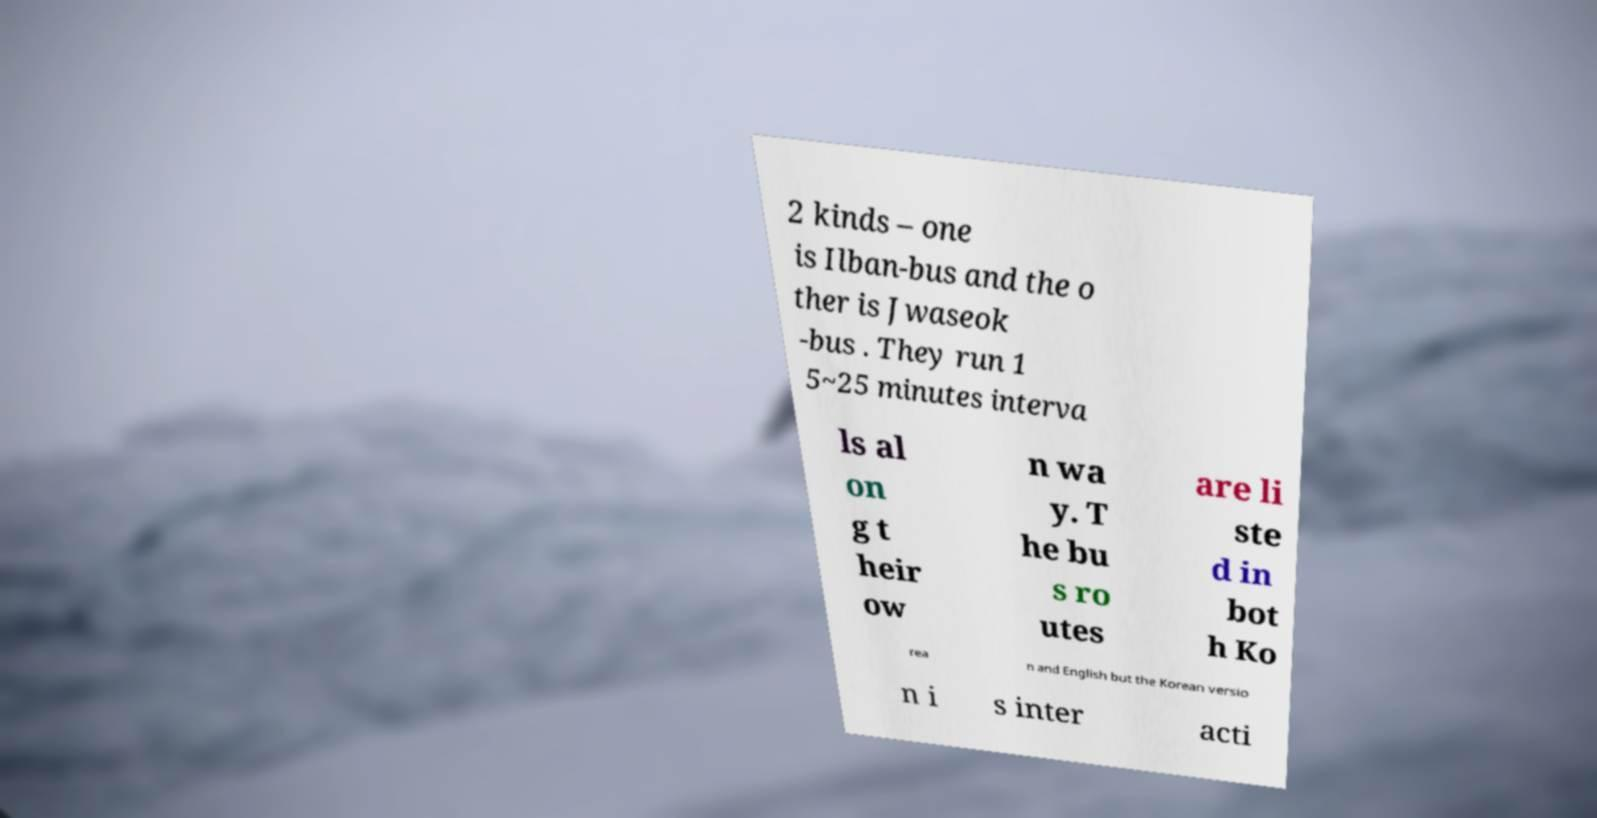Can you accurately transcribe the text from the provided image for me? 2 kinds – one is Ilban-bus and the o ther is Jwaseok -bus . They run 1 5~25 minutes interva ls al on g t heir ow n wa y. T he bu s ro utes are li ste d in bot h Ko rea n and English but the Korean versio n i s inter acti 